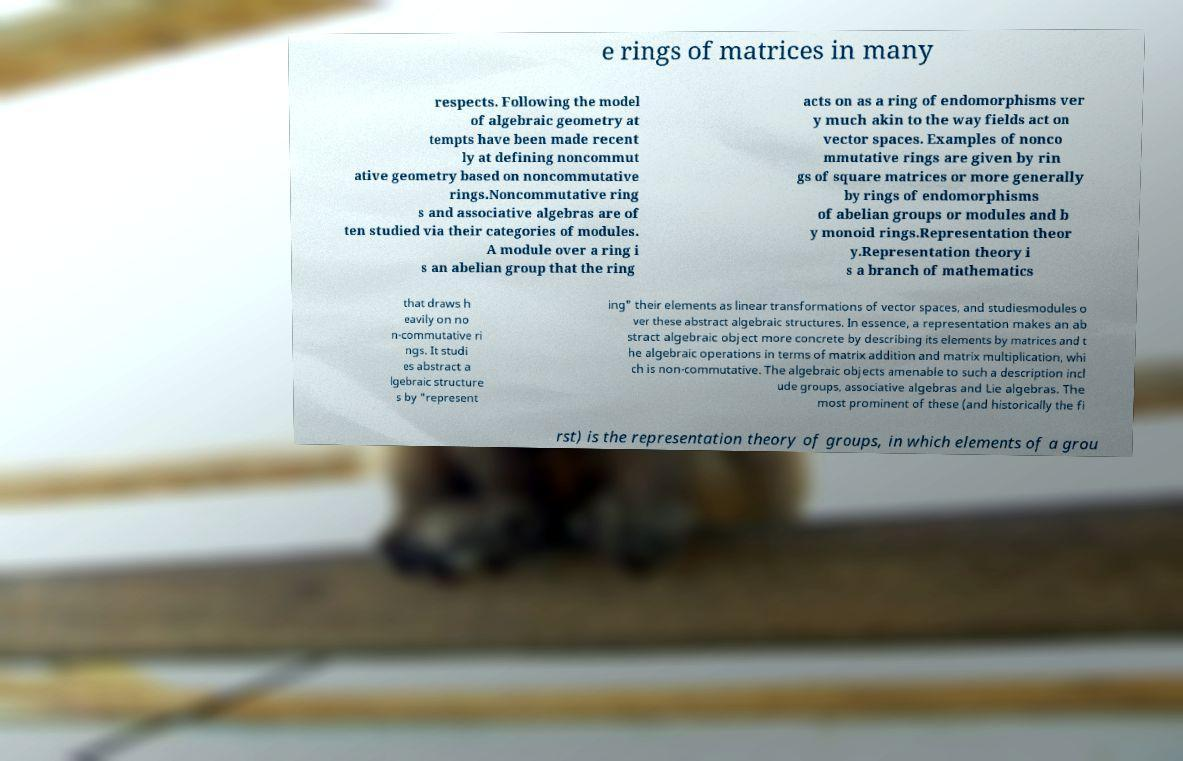Can you accurately transcribe the text from the provided image for me? e rings of matrices in many respects. Following the model of algebraic geometry at tempts have been made recent ly at defining noncommut ative geometry based on noncommutative rings.Noncommutative ring s and associative algebras are of ten studied via their categories of modules. A module over a ring i s an abelian group that the ring acts on as a ring of endomorphisms ver y much akin to the way fields act on vector spaces. Examples of nonco mmutative rings are given by rin gs of square matrices or more generally by rings of endomorphisms of abelian groups or modules and b y monoid rings.Representation theor y.Representation theory i s a branch of mathematics that draws h eavily on no n-commutative ri ngs. It studi es abstract a lgebraic structure s by "represent ing" their elements as linear transformations of vector spaces, and studiesmodules o ver these abstract algebraic structures. In essence, a representation makes an ab stract algebraic object more concrete by describing its elements by matrices and t he algebraic operations in terms of matrix addition and matrix multiplication, whi ch is non-commutative. The algebraic objects amenable to such a description incl ude groups, associative algebras and Lie algebras. The most prominent of these (and historically the fi rst) is the representation theory of groups, in which elements of a grou 